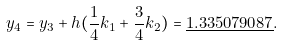<formula> <loc_0><loc_0><loc_500><loc_500>y _ { 4 } = y _ { 3 } + h ( { \frac { 1 } { 4 } } k _ { 1 } + { \frac { 3 } { 4 } } k _ { 2 } ) = { \underline { 1 . 3 3 5 0 7 9 0 8 7 } } .</formula> 